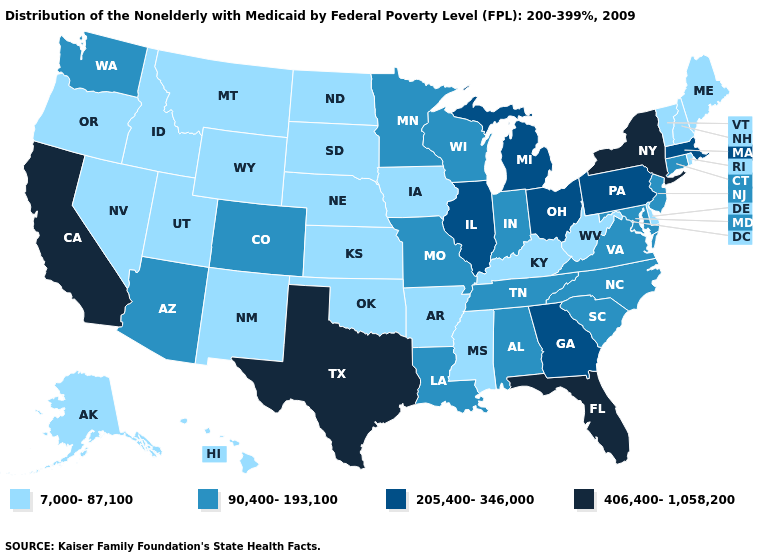Does Nevada have the lowest value in the West?
Write a very short answer. Yes. What is the value of South Carolina?
Answer briefly. 90,400-193,100. What is the value of Pennsylvania?
Keep it brief. 205,400-346,000. What is the lowest value in the West?
Write a very short answer. 7,000-87,100. Does Delaware have a higher value than Missouri?
Short answer required. No. What is the value of New Mexico?
Write a very short answer. 7,000-87,100. Name the states that have a value in the range 406,400-1,058,200?
Answer briefly. California, Florida, New York, Texas. Among the states that border Utah , which have the highest value?
Write a very short answer. Arizona, Colorado. Among the states that border Oregon , which have the highest value?
Give a very brief answer. California. Name the states that have a value in the range 90,400-193,100?
Concise answer only. Alabama, Arizona, Colorado, Connecticut, Indiana, Louisiana, Maryland, Minnesota, Missouri, New Jersey, North Carolina, South Carolina, Tennessee, Virginia, Washington, Wisconsin. How many symbols are there in the legend?
Write a very short answer. 4. Name the states that have a value in the range 406,400-1,058,200?
Keep it brief. California, Florida, New York, Texas. Does Wisconsin have the same value as Maine?
Short answer required. No. Does Kentucky have a higher value than Montana?
Give a very brief answer. No. 